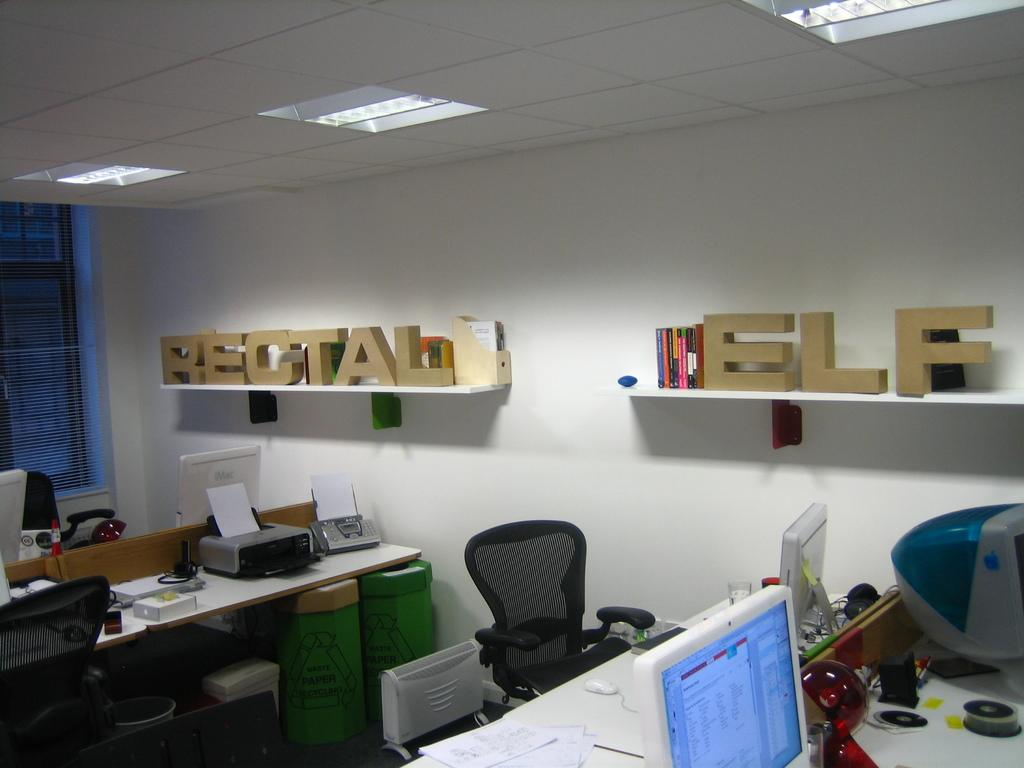What type of room is depicted in the image? The image shows an inner view of an office. What furniture is present in the office? There is a chair and a table in the image. What office equipment can be seen in the image? There is a printer and a monitor in the image. Is there a chess game being played on the table in the image? No, there is no chess game present in the image. Can you see a body lying on the floor in the image? No, there is no body lying on the floor in the image. 